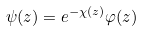Convert formula to latex. <formula><loc_0><loc_0><loc_500><loc_500>\psi ( z ) = e ^ { - \chi ( z ) } \varphi ( z )</formula> 